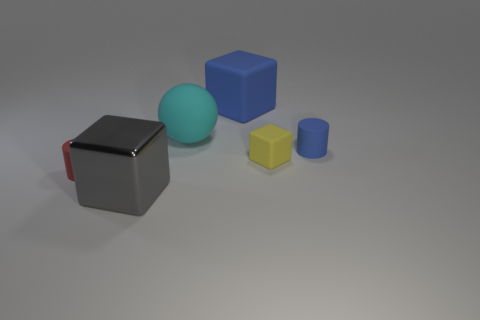There is a cylinder on the right side of the cyan matte thing; how big is it?
Provide a short and direct response. Small. Is the color of the tiny matte cylinder that is behind the red thing the same as the large object to the right of the cyan matte ball?
Offer a terse response. Yes. What material is the big cube that is in front of the matte cylinder that is behind the small rubber cylinder that is to the left of the small blue matte cylinder made of?
Provide a succinct answer. Metal. Is there another object of the same size as the red matte thing?
Your answer should be compact. Yes. There is a gray block that is the same size as the cyan matte object; what is it made of?
Your answer should be very brief. Metal. There is a small blue rubber thing that is to the right of the tiny yellow matte thing; what shape is it?
Keep it short and to the point. Cylinder. Are the large blue thing that is behind the large cyan matte sphere and the object on the left side of the large gray object made of the same material?
Your answer should be compact. Yes. What number of red matte things have the same shape as the large gray object?
Give a very brief answer. 0. What material is the cylinder that is the same color as the big rubber cube?
Ensure brevity in your answer.  Rubber. How many objects are either gray metal blocks or blocks behind the big gray cube?
Provide a succinct answer. 3. 